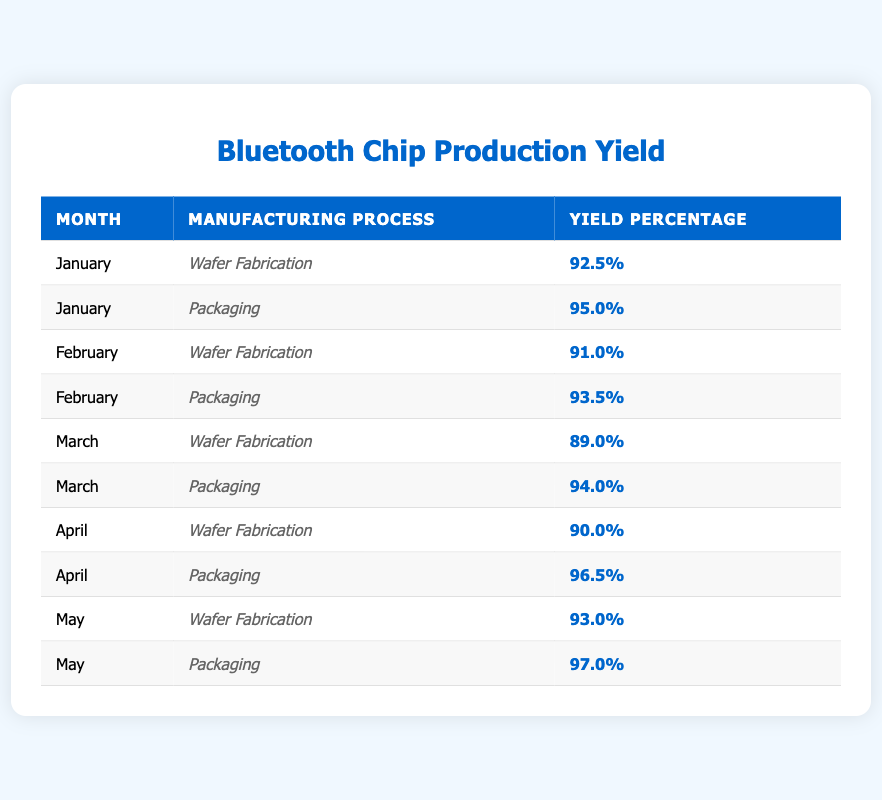What is the yield percentage for Wafer Fabrication in January? The table shows that in January, the yield percentage for the manufacturing process of Wafer Fabrication is 92.5%.
Answer: 92.5% What was the highest yield percentage recorded for Packaging and which month was it? Reviewing the table, the highest yield percentage for Packaging is 97.0%, which occurred in May.
Answer: 97.0% in May What is the average yield percentage for Wafer Fabrication across all the months listed? To find the average yield percentage for Wafer Fabrication, sum the percentages (92.5 + 91.0 + 89.0 + 90.0 + 93.0) = 455.0 and divide by the number of entries (5), resulting in an average of 91.0%.
Answer: 91.0% Was the yield percentage for Packaging in April higher than that in February? In the table, the yield percentage for Packaging in April is 96.5%, while in February it is 93.5%. Since 96.5% is greater than 93.5%, the statement is true.
Answer: Yes In which month did Wafer Fabrication have a yield percentage lower than 90%? Upon inspection of the table, Wafer Fabrication had a yield percentage of 89.0% in March, which is below 90%.
Answer: March What was the difference between the yield percentages for Packaging in May and Wafer Fabrication in March? The yield percentage for Packaging in May is 97.0%, and the yield for Wafer Fabrication in March is 89.0%. The difference is 97.0 - 89.0 = 8.0%.
Answer: 8.0% Is the yield percentage for Packaging consistently higher than Wafer Fabrication for the months listed? By reviewing the data in the table, we see that in every month listed, the yield percentage for Packaging is greater than that for Wafer Fabrication, confirming consistency.
Answer: Yes Which manufacturing process shows a decline in yield percentage from January to March? Analyzing the table, Wafer Fabrication shows a decline from 92.5% in January to 89.0% in March, indicating negative change over this period.
Answer: Wafer Fabrication What was the lowest yield percentage recorded for both manufacturing processes in February? The lowest yield percentage recorded in February is 91.0% for Wafer Fabrication and 93.5% for Packaging. Therefore, the overall lowest is 91.0% for Wafer Fabrication.
Answer: 91.0% 